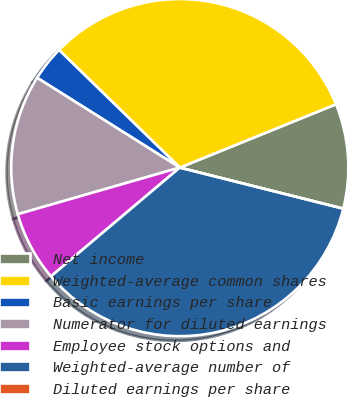Convert chart. <chart><loc_0><loc_0><loc_500><loc_500><pie_chart><fcel>Net income<fcel>Weighted-average common shares<fcel>Basic earnings per share<fcel>Numerator for diluted earnings<fcel>Employee stock options and<fcel>Weighted-average number of<fcel>Diluted earnings per share<nl><fcel>10.05%<fcel>31.58%<fcel>3.35%<fcel>13.4%<fcel>6.7%<fcel>34.93%<fcel>0.0%<nl></chart> 